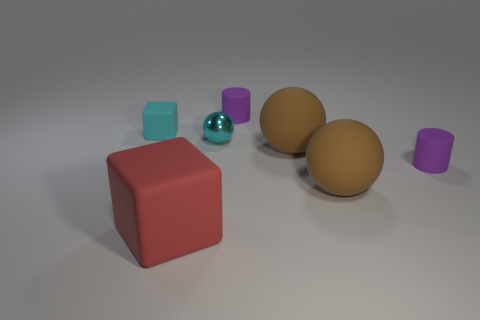What shape is the small object that is the same color as the small matte block?
Ensure brevity in your answer.  Sphere. What number of purple cylinders have the same size as the red object?
Ensure brevity in your answer.  0. There is a cyan object that is in front of the cyan rubber thing; does it have the same size as the purple thing that is behind the tiny cyan ball?
Keep it short and to the point. Yes. How many objects are either big green matte spheres or small rubber objects behind the cyan matte thing?
Provide a short and direct response. 1. The small ball has what color?
Offer a very short reply. Cyan. What material is the block in front of the cyan object to the left of the matte block in front of the small cyan metallic ball?
Make the answer very short. Rubber. There is a cyan block that is made of the same material as the large red thing; what size is it?
Your response must be concise. Small. Are there any rubber cylinders that have the same color as the large cube?
Your answer should be very brief. No. Is the size of the red rubber object the same as the rubber cube that is behind the metal thing?
Your answer should be very brief. No. There is a cyan thing to the left of the rubber block that is on the right side of the tiny cyan rubber block; how many tiny rubber cylinders are in front of it?
Make the answer very short. 1. 